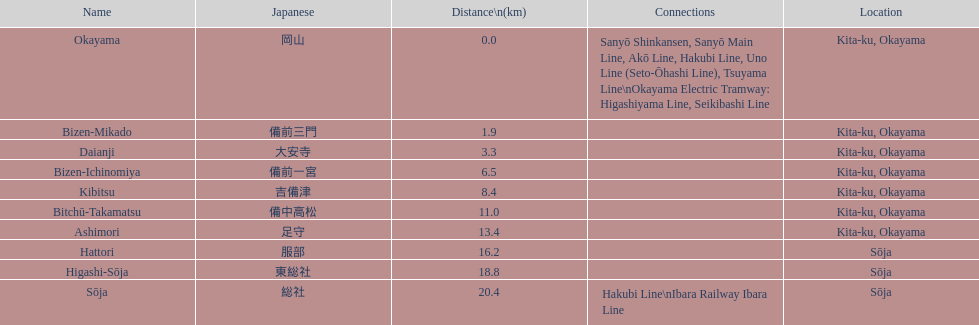Which stations have connections to other lines? Okayama, Sōja. 